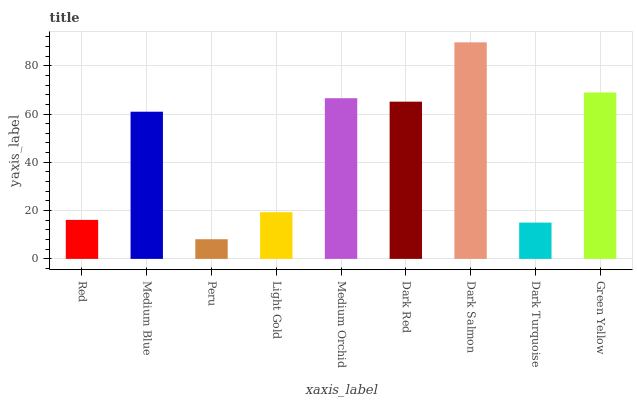Is Medium Blue the minimum?
Answer yes or no. No. Is Medium Blue the maximum?
Answer yes or no. No. Is Medium Blue greater than Red?
Answer yes or no. Yes. Is Red less than Medium Blue?
Answer yes or no. Yes. Is Red greater than Medium Blue?
Answer yes or no. No. Is Medium Blue less than Red?
Answer yes or no. No. Is Medium Blue the high median?
Answer yes or no. Yes. Is Medium Blue the low median?
Answer yes or no. Yes. Is Dark Turquoise the high median?
Answer yes or no. No. Is Light Gold the low median?
Answer yes or no. No. 